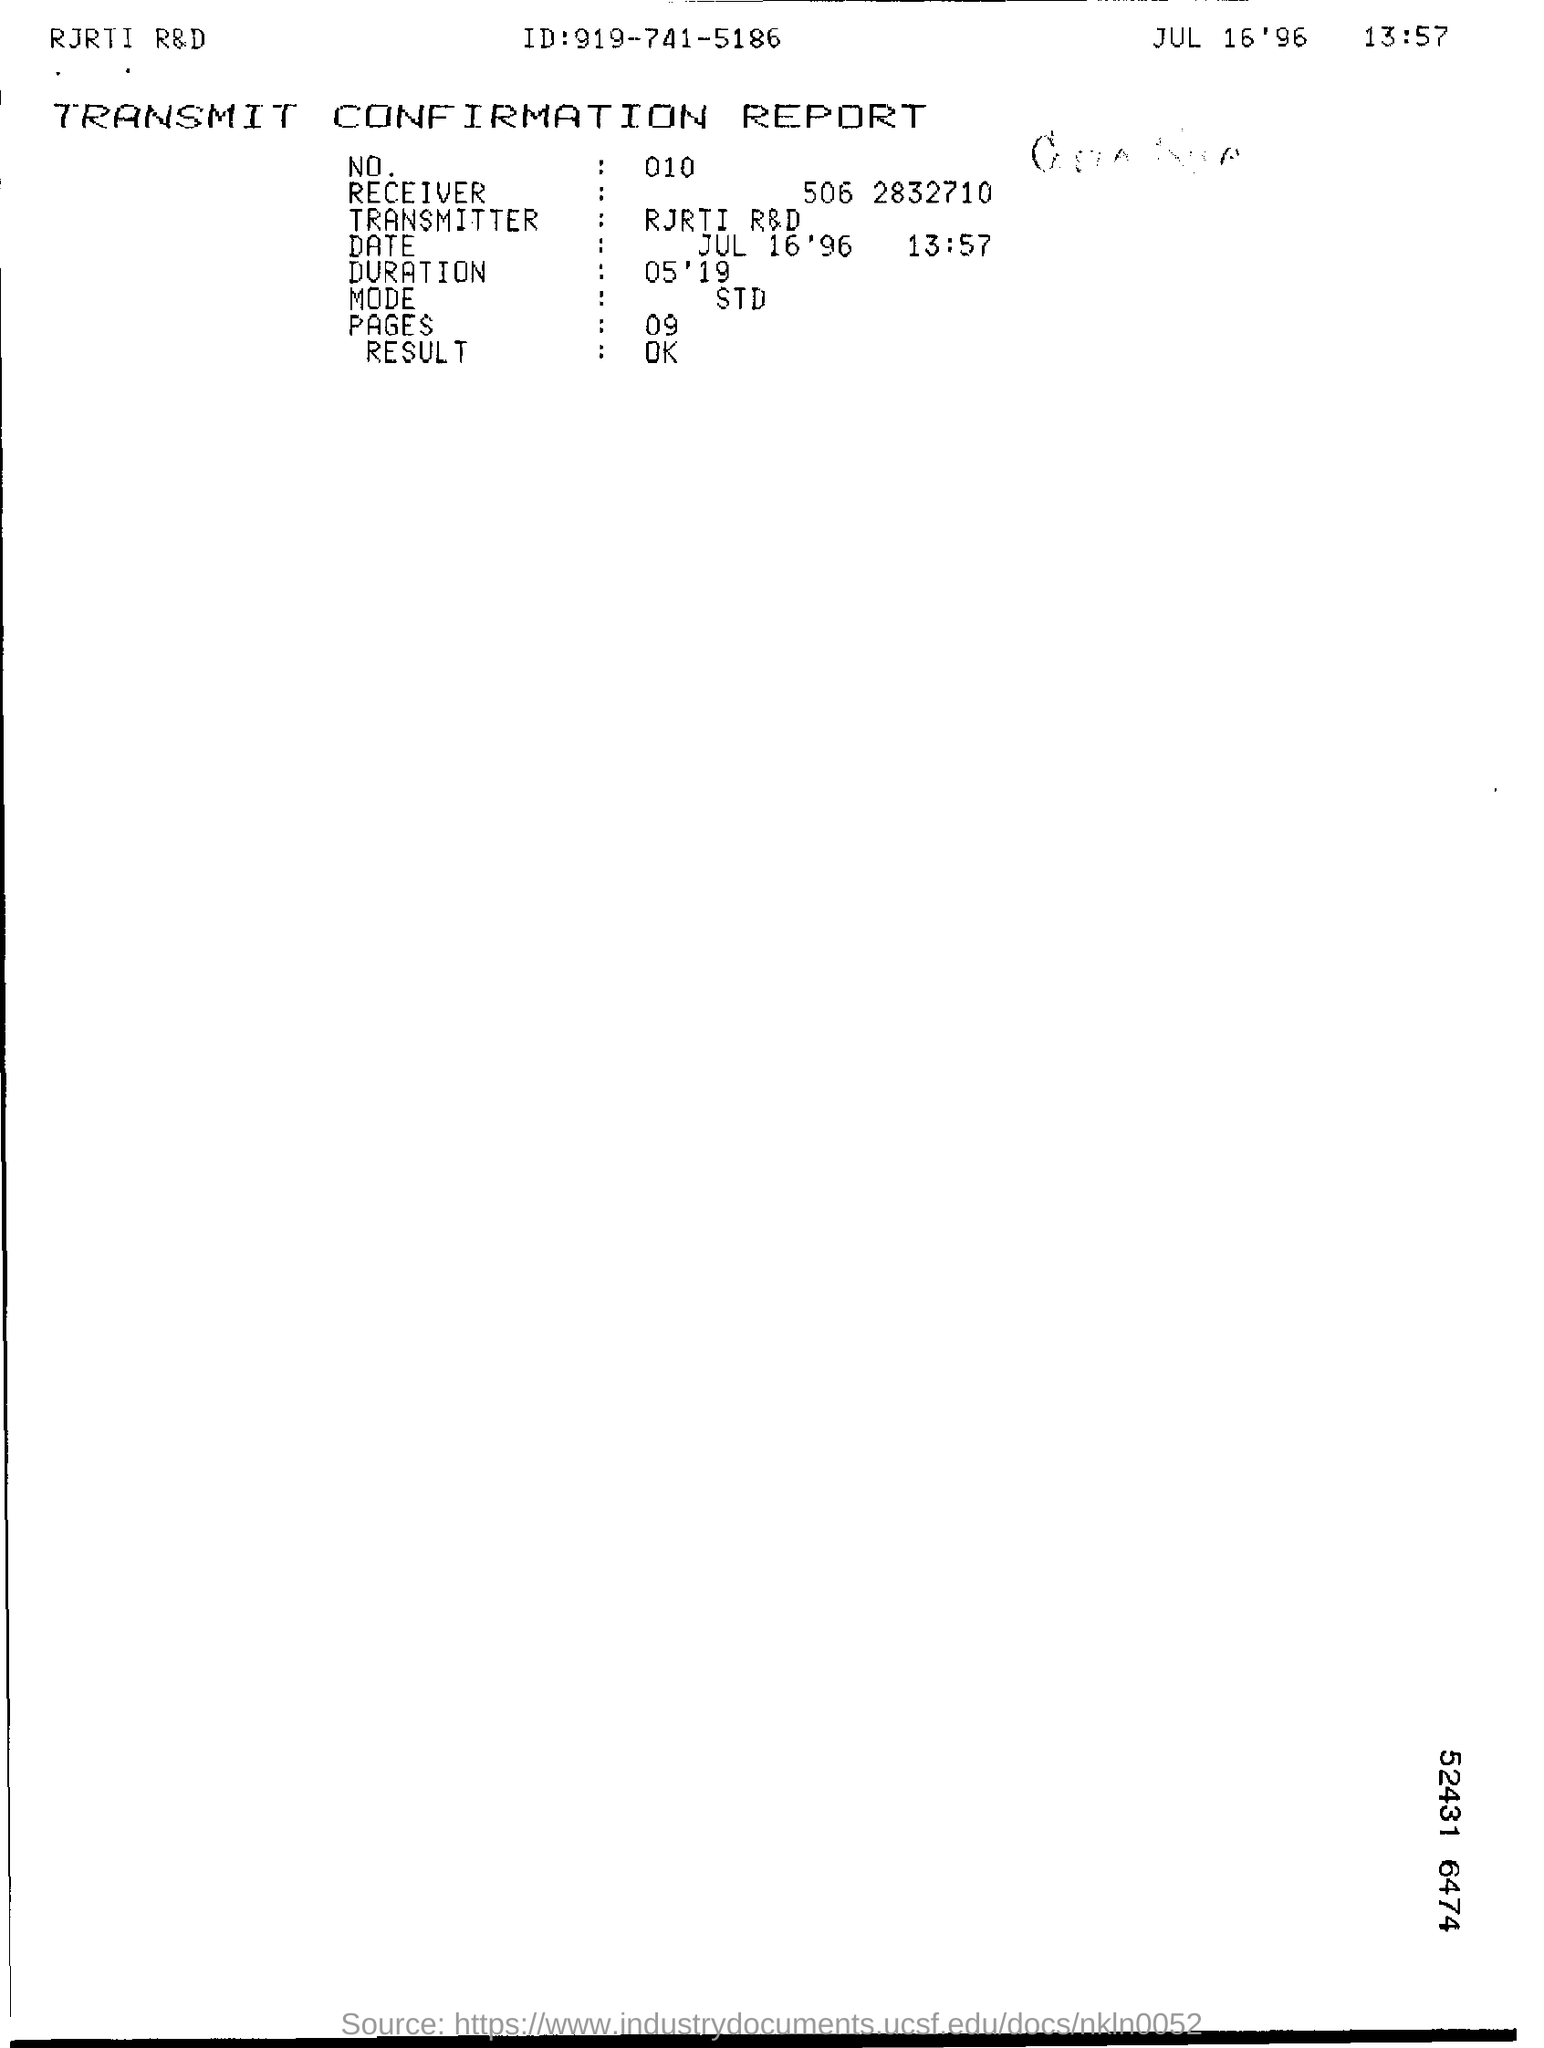List a handful of essential elements in this visual. This document bears the heading 'TRANSMIT CONFIRMATION REPORT.' 